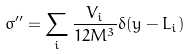<formula> <loc_0><loc_0><loc_500><loc_500>\sigma ^ { \prime \prime } = \sum _ { i } \frac { V _ { i } } { 1 2 M ^ { 3 } } \delta ( y - L _ { i } )</formula> 